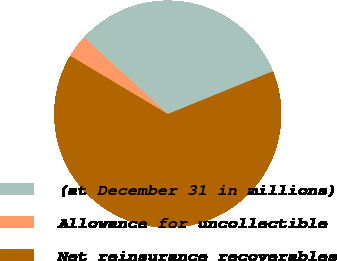<chart> <loc_0><loc_0><loc_500><loc_500><pie_chart><fcel>(at December 31 in millions)<fcel>Allowance for uncollectible<fcel>Net reinsurance recoverables<nl><fcel>32.05%<fcel>3.23%<fcel>64.72%<nl></chart> 